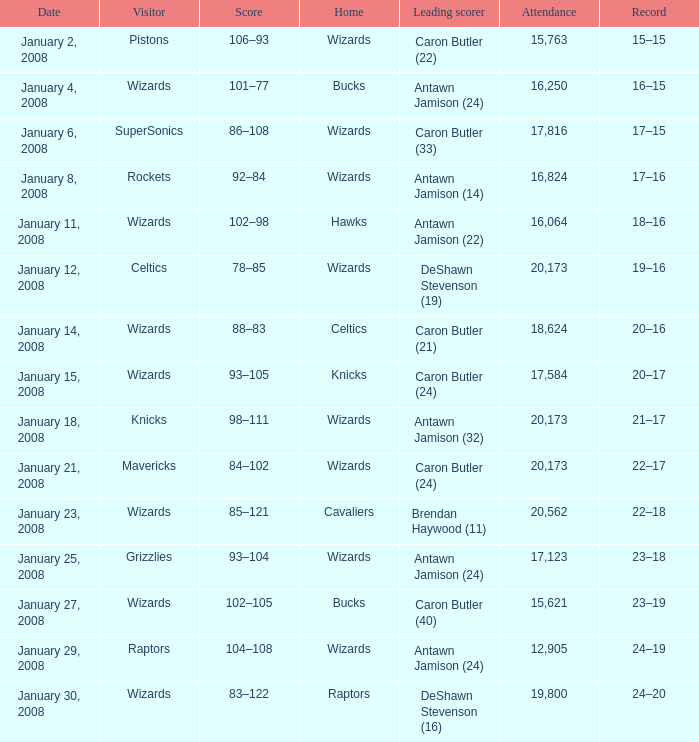What was the attendance count on january 4, 2008? 16250.0. 